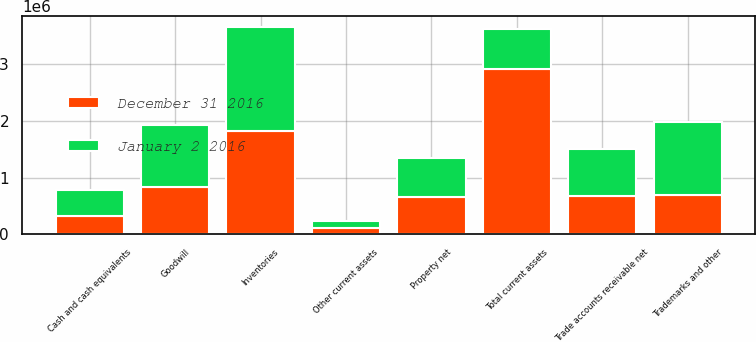<chart> <loc_0><loc_0><loc_500><loc_500><stacked_bar_chart><ecel><fcel>Cash and cash equivalents<fcel>Trade accounts receivable net<fcel>Inventories<fcel>Other current assets<fcel>Total current assets<fcel>Property net<fcel>Trademarks and other<fcel>Goodwill<nl><fcel>January 2 2016<fcel>460245<fcel>814178<fcel>1.84056e+06<fcel>137535<fcel>700515<fcel>692464<fcel>1.28546e+06<fcel>1.09854e+06<nl><fcel>December 31 2016<fcel>319169<fcel>680417<fcel>1.8146e+06<fcel>103679<fcel>2.91787e+06<fcel>650462<fcel>700515<fcel>834315<nl></chart> 